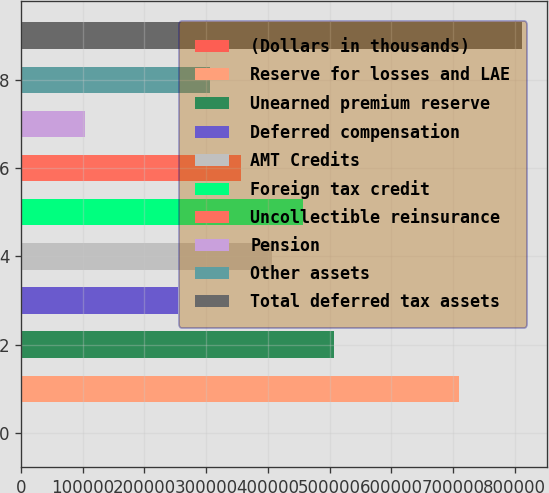<chart> <loc_0><loc_0><loc_500><loc_500><bar_chart><fcel>(Dollars in thousands)<fcel>Reserve for losses and LAE<fcel>Unearned premium reserve<fcel>Deferred compensation<fcel>AMT Credits<fcel>Foreign tax credit<fcel>Uncollectible reinsurance<fcel>Pension<fcel>Other assets<fcel>Total deferred tax assets<nl><fcel>2006<fcel>710225<fcel>507877<fcel>254942<fcel>406703<fcel>457290<fcel>356116<fcel>103180<fcel>305529<fcel>811400<nl></chart> 